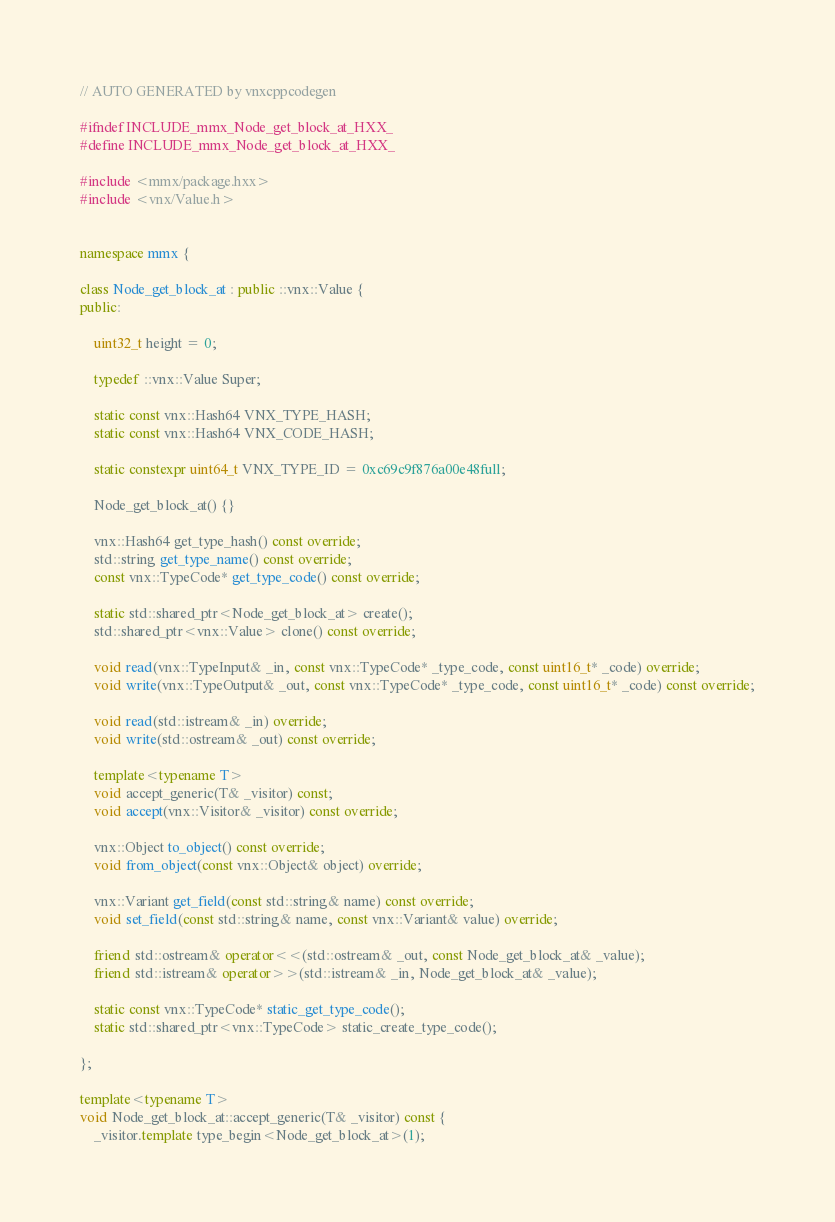<code> <loc_0><loc_0><loc_500><loc_500><_C++_>
// AUTO GENERATED by vnxcppcodegen

#ifndef INCLUDE_mmx_Node_get_block_at_HXX_
#define INCLUDE_mmx_Node_get_block_at_HXX_

#include <mmx/package.hxx>
#include <vnx/Value.h>


namespace mmx {

class Node_get_block_at : public ::vnx::Value {
public:
	
	uint32_t height = 0;
	
	typedef ::vnx::Value Super;
	
	static const vnx::Hash64 VNX_TYPE_HASH;
	static const vnx::Hash64 VNX_CODE_HASH;
	
	static constexpr uint64_t VNX_TYPE_ID = 0xc69c9f876a00e48full;
	
	Node_get_block_at() {}
	
	vnx::Hash64 get_type_hash() const override;
	std::string get_type_name() const override;
	const vnx::TypeCode* get_type_code() const override;
	
	static std::shared_ptr<Node_get_block_at> create();
	std::shared_ptr<vnx::Value> clone() const override;
	
	void read(vnx::TypeInput& _in, const vnx::TypeCode* _type_code, const uint16_t* _code) override;
	void write(vnx::TypeOutput& _out, const vnx::TypeCode* _type_code, const uint16_t* _code) const override;
	
	void read(std::istream& _in) override;
	void write(std::ostream& _out) const override;
	
	template<typename T>
	void accept_generic(T& _visitor) const;
	void accept(vnx::Visitor& _visitor) const override;
	
	vnx::Object to_object() const override;
	void from_object(const vnx::Object& object) override;
	
	vnx::Variant get_field(const std::string& name) const override;
	void set_field(const std::string& name, const vnx::Variant& value) override;
	
	friend std::ostream& operator<<(std::ostream& _out, const Node_get_block_at& _value);
	friend std::istream& operator>>(std::istream& _in, Node_get_block_at& _value);
	
	static const vnx::TypeCode* static_get_type_code();
	static std::shared_ptr<vnx::TypeCode> static_create_type_code();
	
};

template<typename T>
void Node_get_block_at::accept_generic(T& _visitor) const {
	_visitor.template type_begin<Node_get_block_at>(1);</code> 